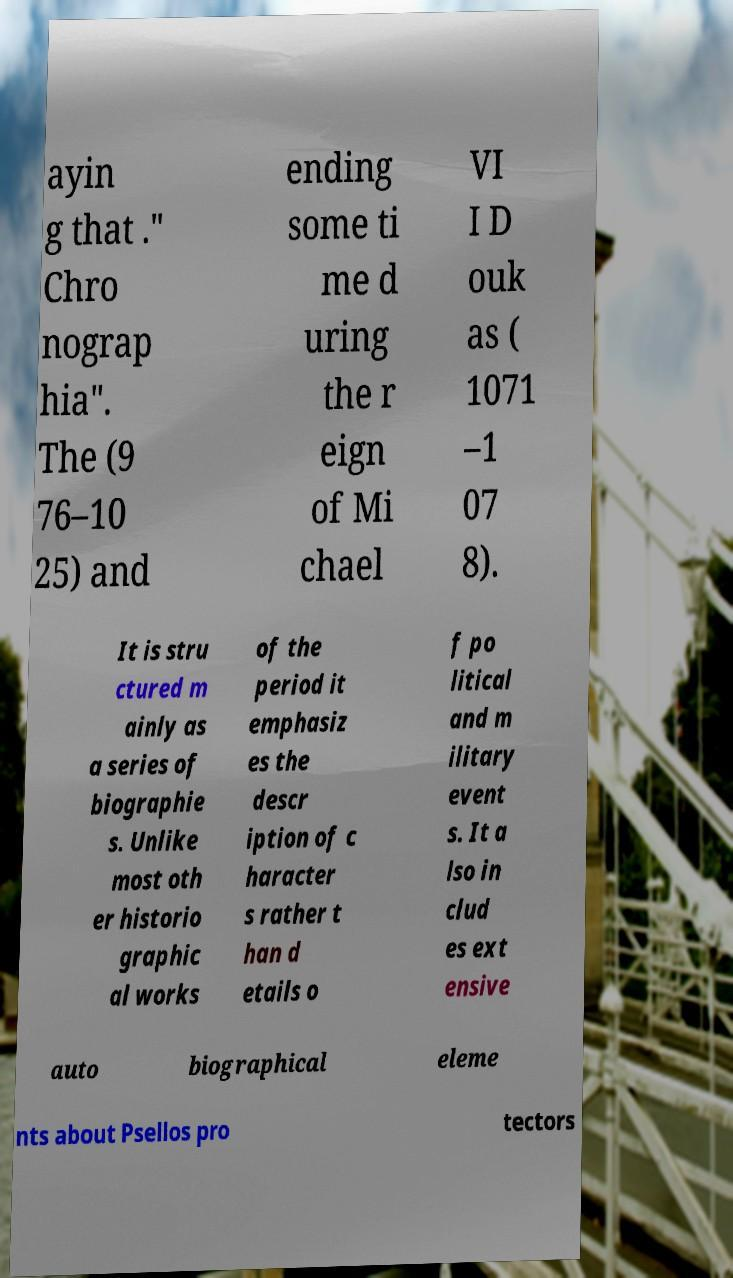Please read and relay the text visible in this image. What does it say? ayin g that ." Chro nograp hia". The (9 76–10 25) and ending some ti me d uring the r eign of Mi chael VI I D ouk as ( 1071 –1 07 8). It is stru ctured m ainly as a series of biographie s. Unlike most oth er historio graphic al works of the period it emphasiz es the descr iption of c haracter s rather t han d etails o f po litical and m ilitary event s. It a lso in clud es ext ensive auto biographical eleme nts about Psellos pro tectors 